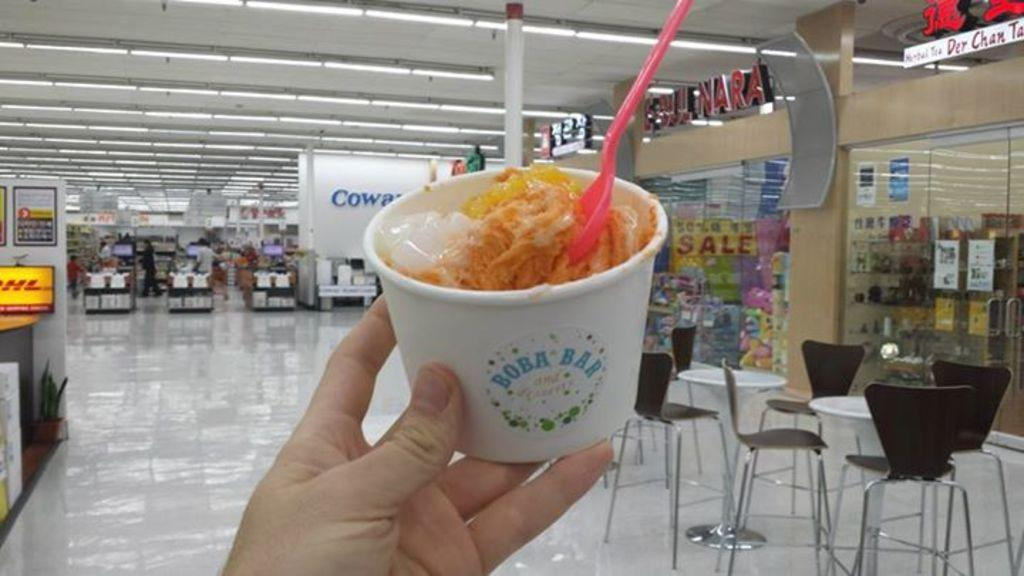What is in the cup that is visible in the image? There is a cup of ice cream in the image. What is used to eat the ice cream in the image? There is a spoon in the cup of ice cream. Who is holding the cup of ice cream in the image? A person is holding the cup of ice cream. What type of furniture can be seen in the background of the image? There are chairs and tables in the background of the image. What can be seen inside the store in the background of the image? There are items inside the store in the background of the image. What type of tub is visible in the image? There is no tub present in the image. Can you describe the detail of the cough in the image? There is no cough present in the image. 